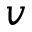<formula> <loc_0><loc_0><loc_500><loc_500>v</formula> 